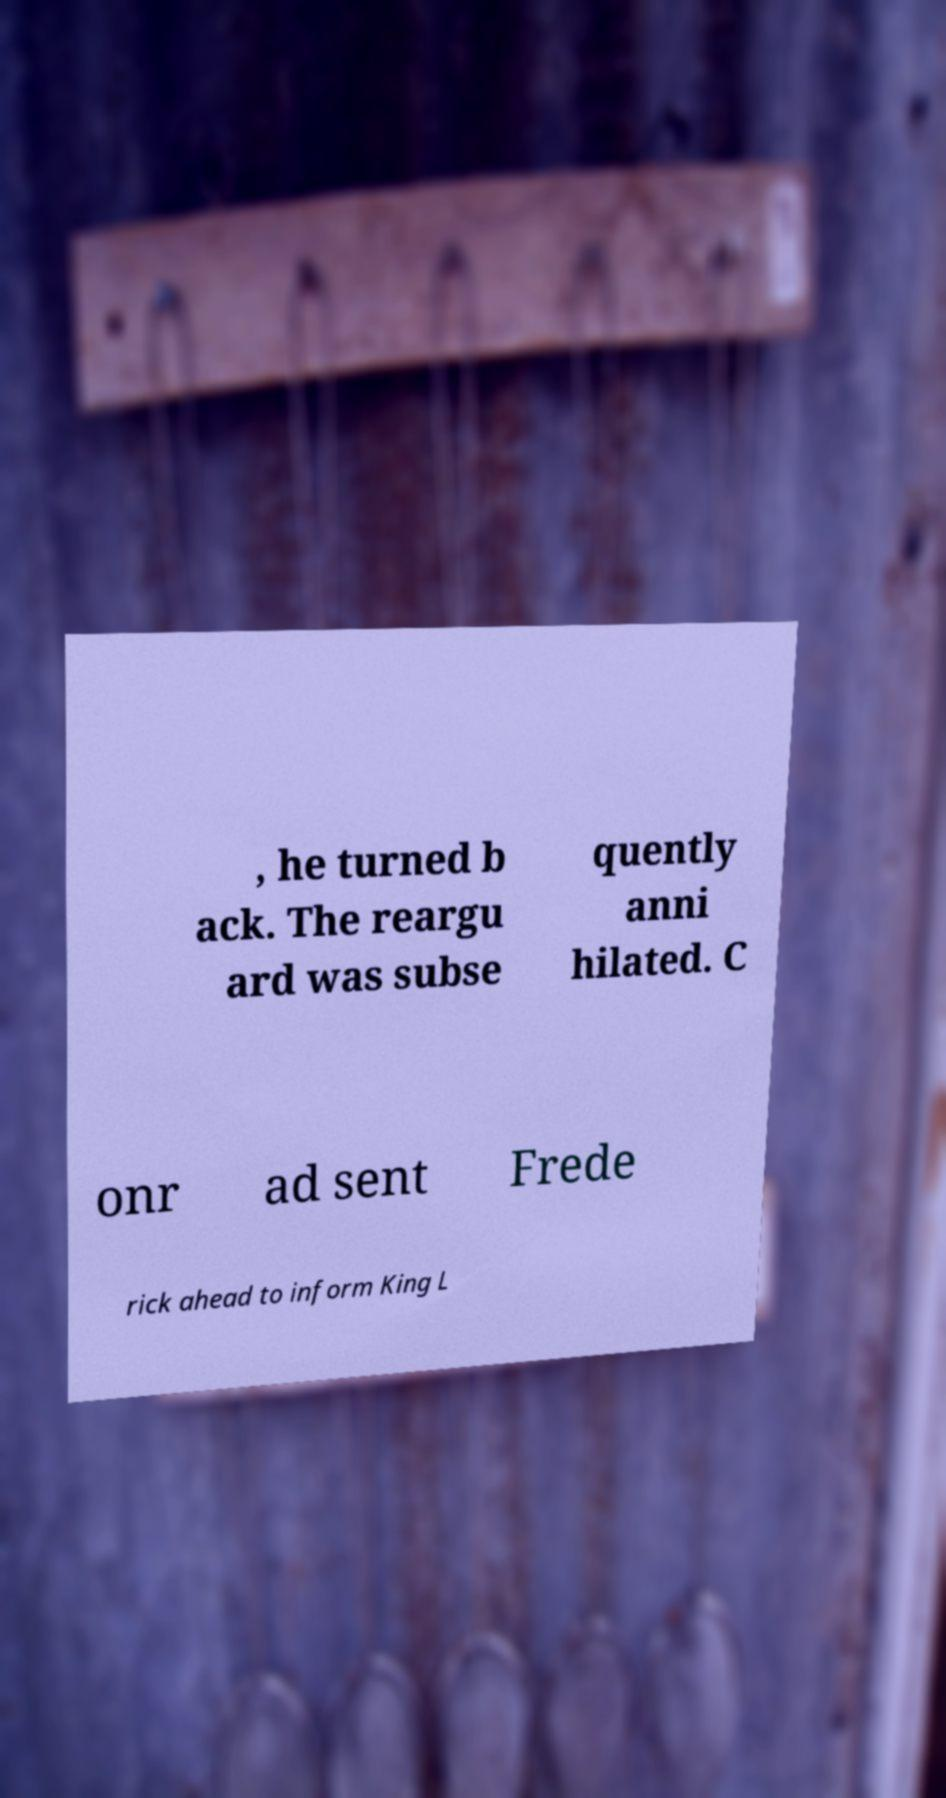Can you read and provide the text displayed in the image?This photo seems to have some interesting text. Can you extract and type it out for me? , he turned b ack. The reargu ard was subse quently anni hilated. C onr ad sent Frede rick ahead to inform King L 